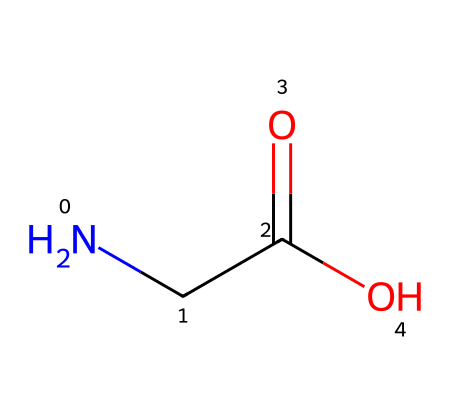What is the functional group present in this chemical? This chemical contains a carboxylic acid functional group, indicated by the -COOH structure.
Answer: carboxylic acid How many carbon atoms are in this molecule? The SMILES representation shows one carbon atom (C) in the structure.
Answer: 1 What type of molecule is represented here? The structure is characteristic of an amino acid, as indicated by the presence of both an amine group (-NH2) and a carboxylic acid group (-COOH).
Answer: amino acid How many nitrogen atoms are in this molecule? The SMILES notation reveals one nitrogen atom (N) present in the structure.
Answer: 1 What is the total number of oxygen atoms in this structure? There are two oxygen atoms present, as indicated by the -COOH functional group.
Answer: 2 Identify the number of hydrogen atoms in this molecule. Analyzing the structure, we can determine that there are four hydrogen atoms in total surrounding the nitrogen and the carbon.
Answer: 4 What type of bond exists between the nitrogen atom and the alpha carbon? The bond between the nitrogen atom and the alpha carbon is a single covalent bond, as seen from the lack of any double or triple bond connection in the SMILES representation.
Answer: single covalent bond 